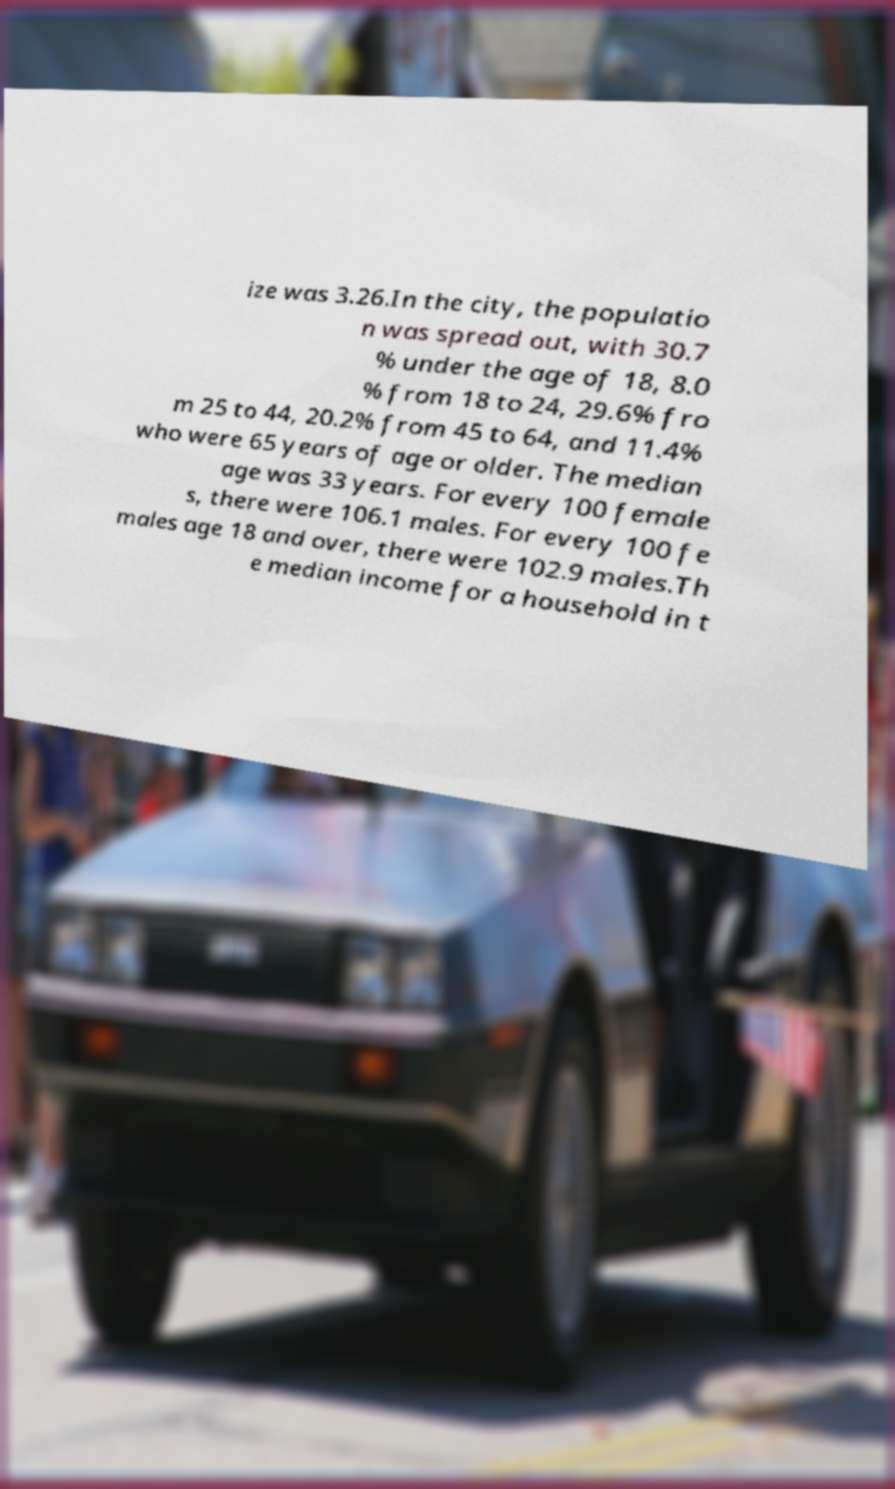Please read and relay the text visible in this image. What does it say? ize was 3.26.In the city, the populatio n was spread out, with 30.7 % under the age of 18, 8.0 % from 18 to 24, 29.6% fro m 25 to 44, 20.2% from 45 to 64, and 11.4% who were 65 years of age or older. The median age was 33 years. For every 100 female s, there were 106.1 males. For every 100 fe males age 18 and over, there were 102.9 males.Th e median income for a household in t 